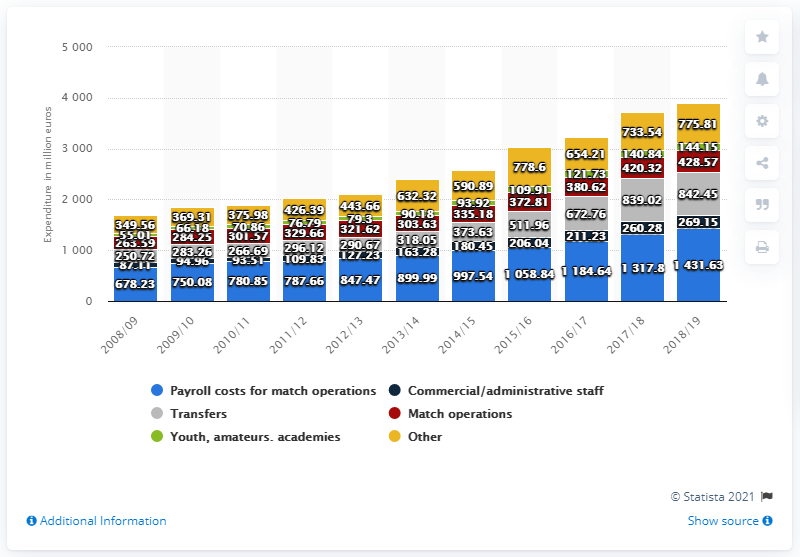List a handful of essential elements in this visual. The German Bundesliga spent a total of 842.45 million euros on transfers in the 2018/19 season. 